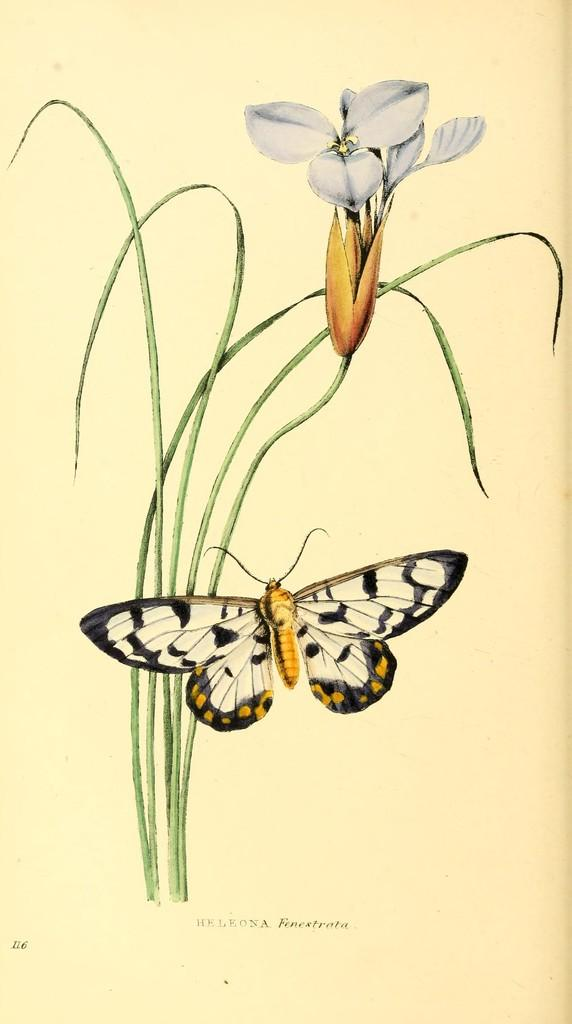What is depicted in the art in the image? There is an art of a flower plant in the image. What can be seen in front of the flower plant in the image? There is a butterfly in front of the flower plant in the image. What material is the art drawn or painted on? The art is on a paper. How many pears are visible in the image? There are no pears present in the image. What type of nerve is connected to the butterfly in the image? There are no nerves present in the image, as it is an artistic representation of a flower plant and a butterfly. 